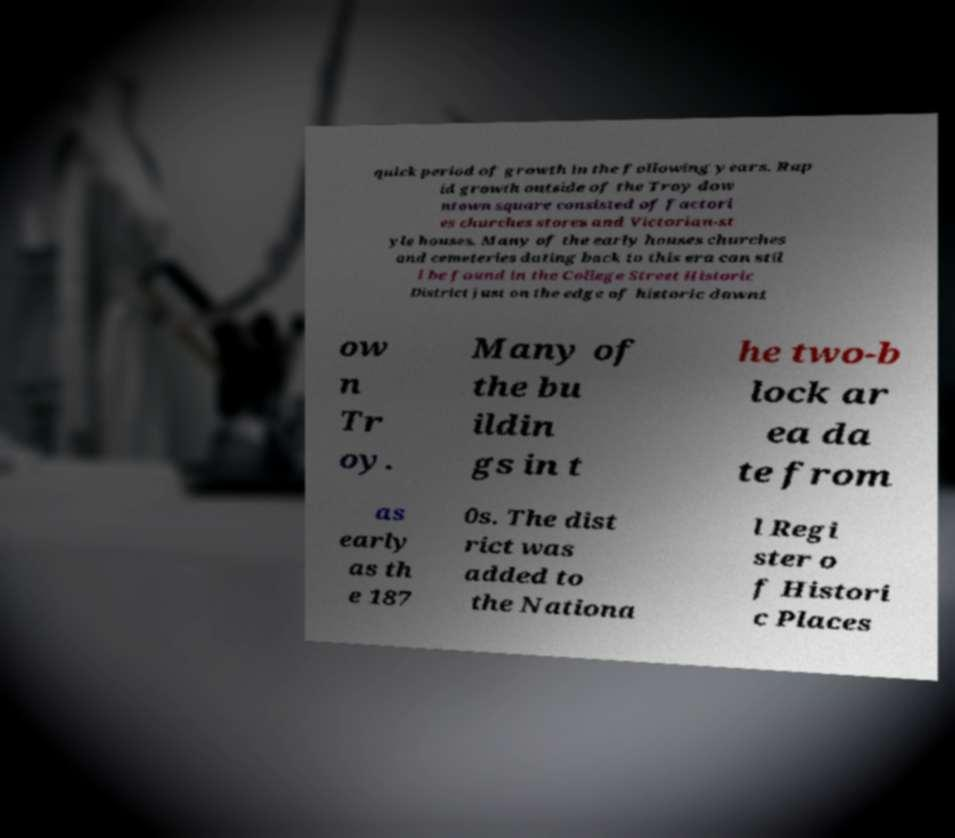Could you extract and type out the text from this image? quick period of growth in the following years. Rap id growth outside of the Troy dow ntown square consisted of factori es churches stores and Victorian-st yle houses. Many of the early houses churches and cemeteries dating back to this era can stil l be found in the College Street Historic District just on the edge of historic downt ow n Tr oy. Many of the bu ildin gs in t he two-b lock ar ea da te from as early as th e 187 0s. The dist rict was added to the Nationa l Regi ster o f Histori c Places 